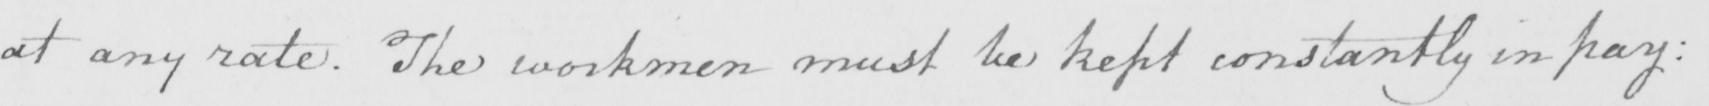Can you read and transcribe this handwriting? at any rate . The workmen must be kept constantly in pay : 